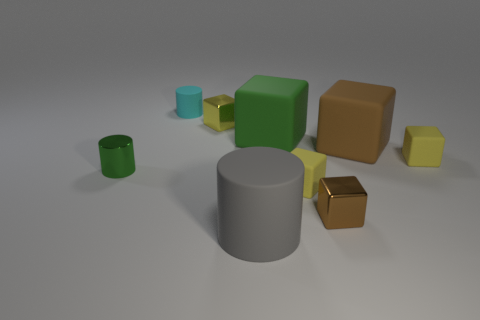Subtract all metal cubes. How many cubes are left? 4 Add 1 green things. How many objects exist? 10 Subtract all green cylinders. How many brown cubes are left? 2 Subtract 2 blocks. How many blocks are left? 4 Subtract all brown blocks. How many blocks are left? 4 Subtract all cubes. How many objects are left? 3 Subtract all red cylinders. Subtract all green cubes. How many cylinders are left? 3 Add 8 shiny cubes. How many shiny cubes are left? 10 Add 7 large yellow shiny spheres. How many large yellow shiny spheres exist? 7 Subtract 0 cyan cubes. How many objects are left? 9 